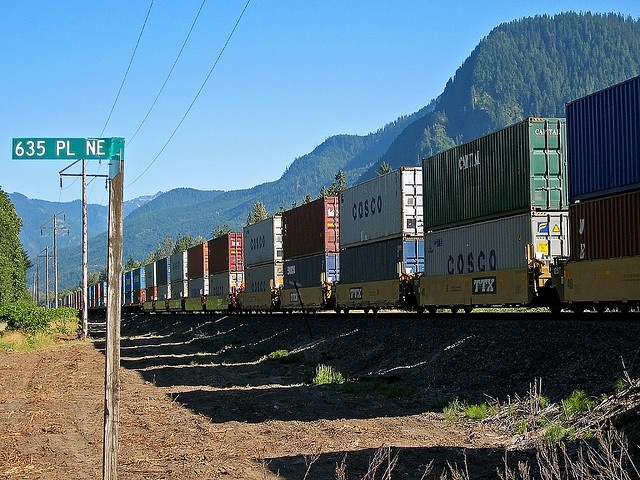Describe the objects in this image and their specific colors. I can see a train in lightblue, black, purple, and navy tones in this image. 